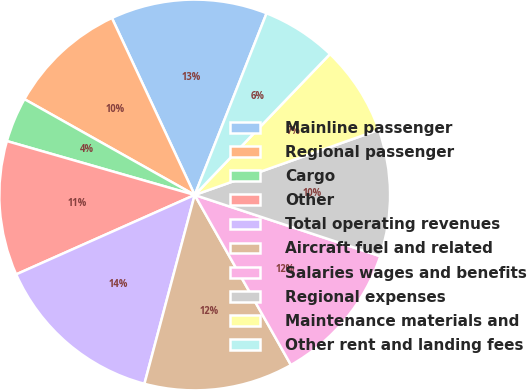<chart> <loc_0><loc_0><loc_500><loc_500><pie_chart><fcel>Mainline passenger<fcel>Regional passenger<fcel>Cargo<fcel>Other<fcel>Total operating revenues<fcel>Aircraft fuel and related<fcel>Salaries wages and benefits<fcel>Regional expenses<fcel>Maintenance materials and<fcel>Other rent and landing fees<nl><fcel>12.96%<fcel>9.88%<fcel>3.71%<fcel>11.11%<fcel>14.2%<fcel>12.34%<fcel>11.73%<fcel>10.49%<fcel>7.41%<fcel>6.18%<nl></chart> 